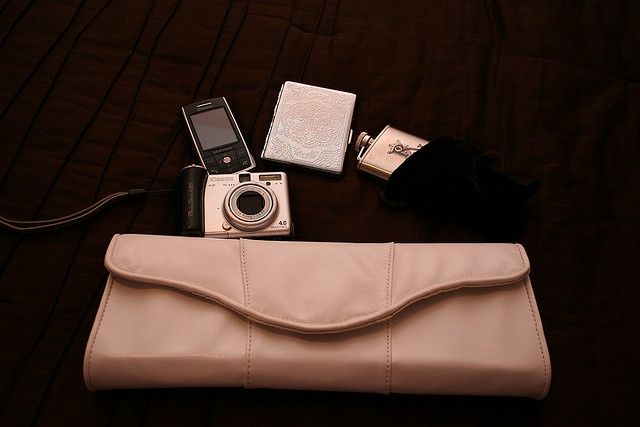Describe the objects in this image and their specific colors. I can see handbag in black, tan, salmon, brown, and maroon tones and cell phone in black, gray, and lightgray tones in this image. 